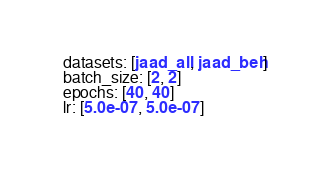<code> <loc_0><loc_0><loc_500><loc_500><_YAML_>  datasets: [jaad_all, jaad_beh]
  batch_size: [2, 2]
  epochs: [40, 40]
  lr: [5.0e-07, 5.0e-07]
</code> 